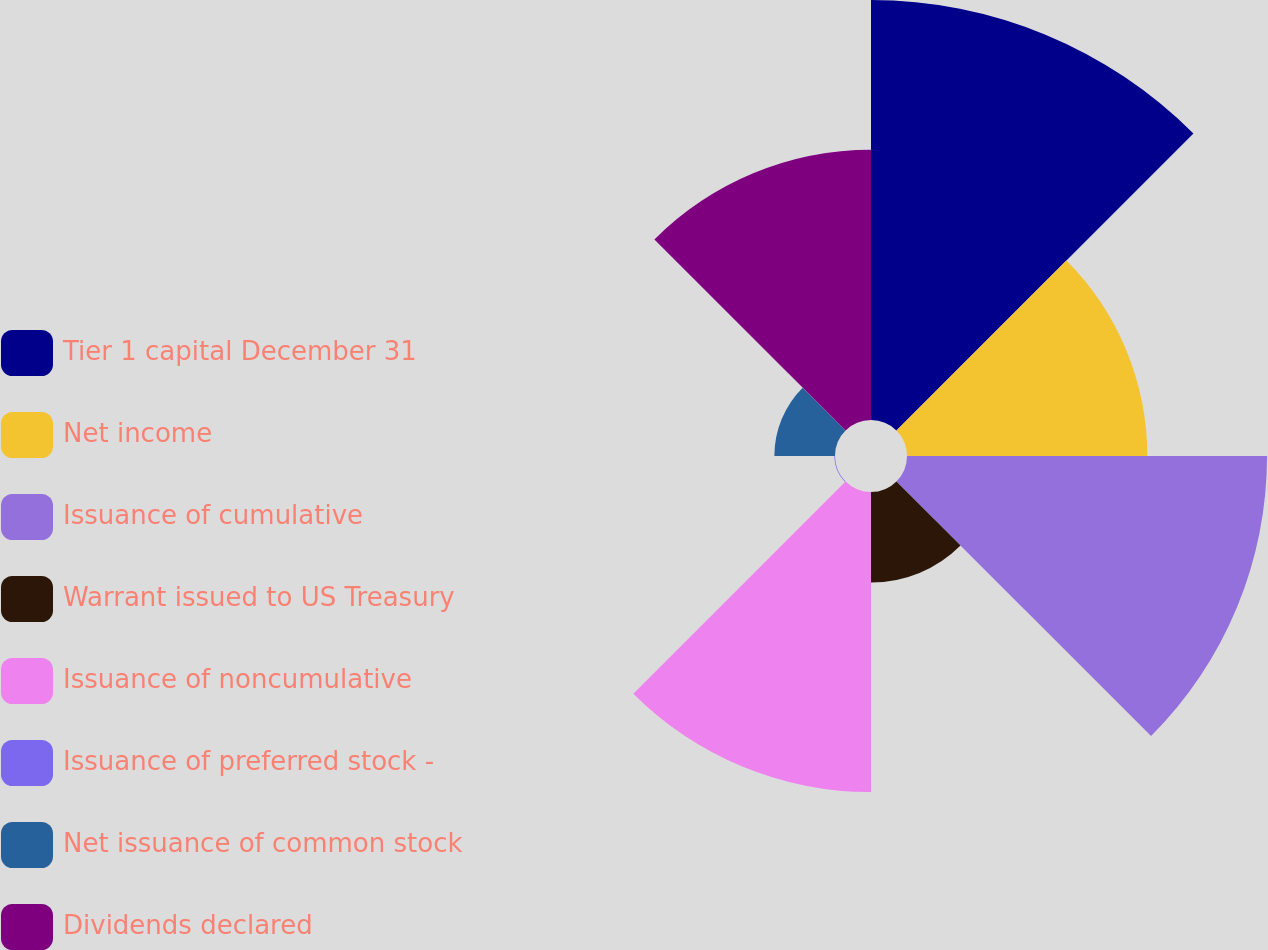Convert chart. <chart><loc_0><loc_0><loc_500><loc_500><pie_chart><fcel>Tier 1 capital December 31<fcel>Net income<fcel>Issuance of cumulative<fcel>Warrant issued to US Treasury<fcel>Issuance of noncumulative<fcel>Issuance of preferred stock -<fcel>Net issuance of common stock<fcel>Dividends declared<nl><fcel>24.1%<fcel>13.79%<fcel>20.66%<fcel>5.2%<fcel>17.22%<fcel>0.04%<fcel>3.48%<fcel>15.51%<nl></chart> 